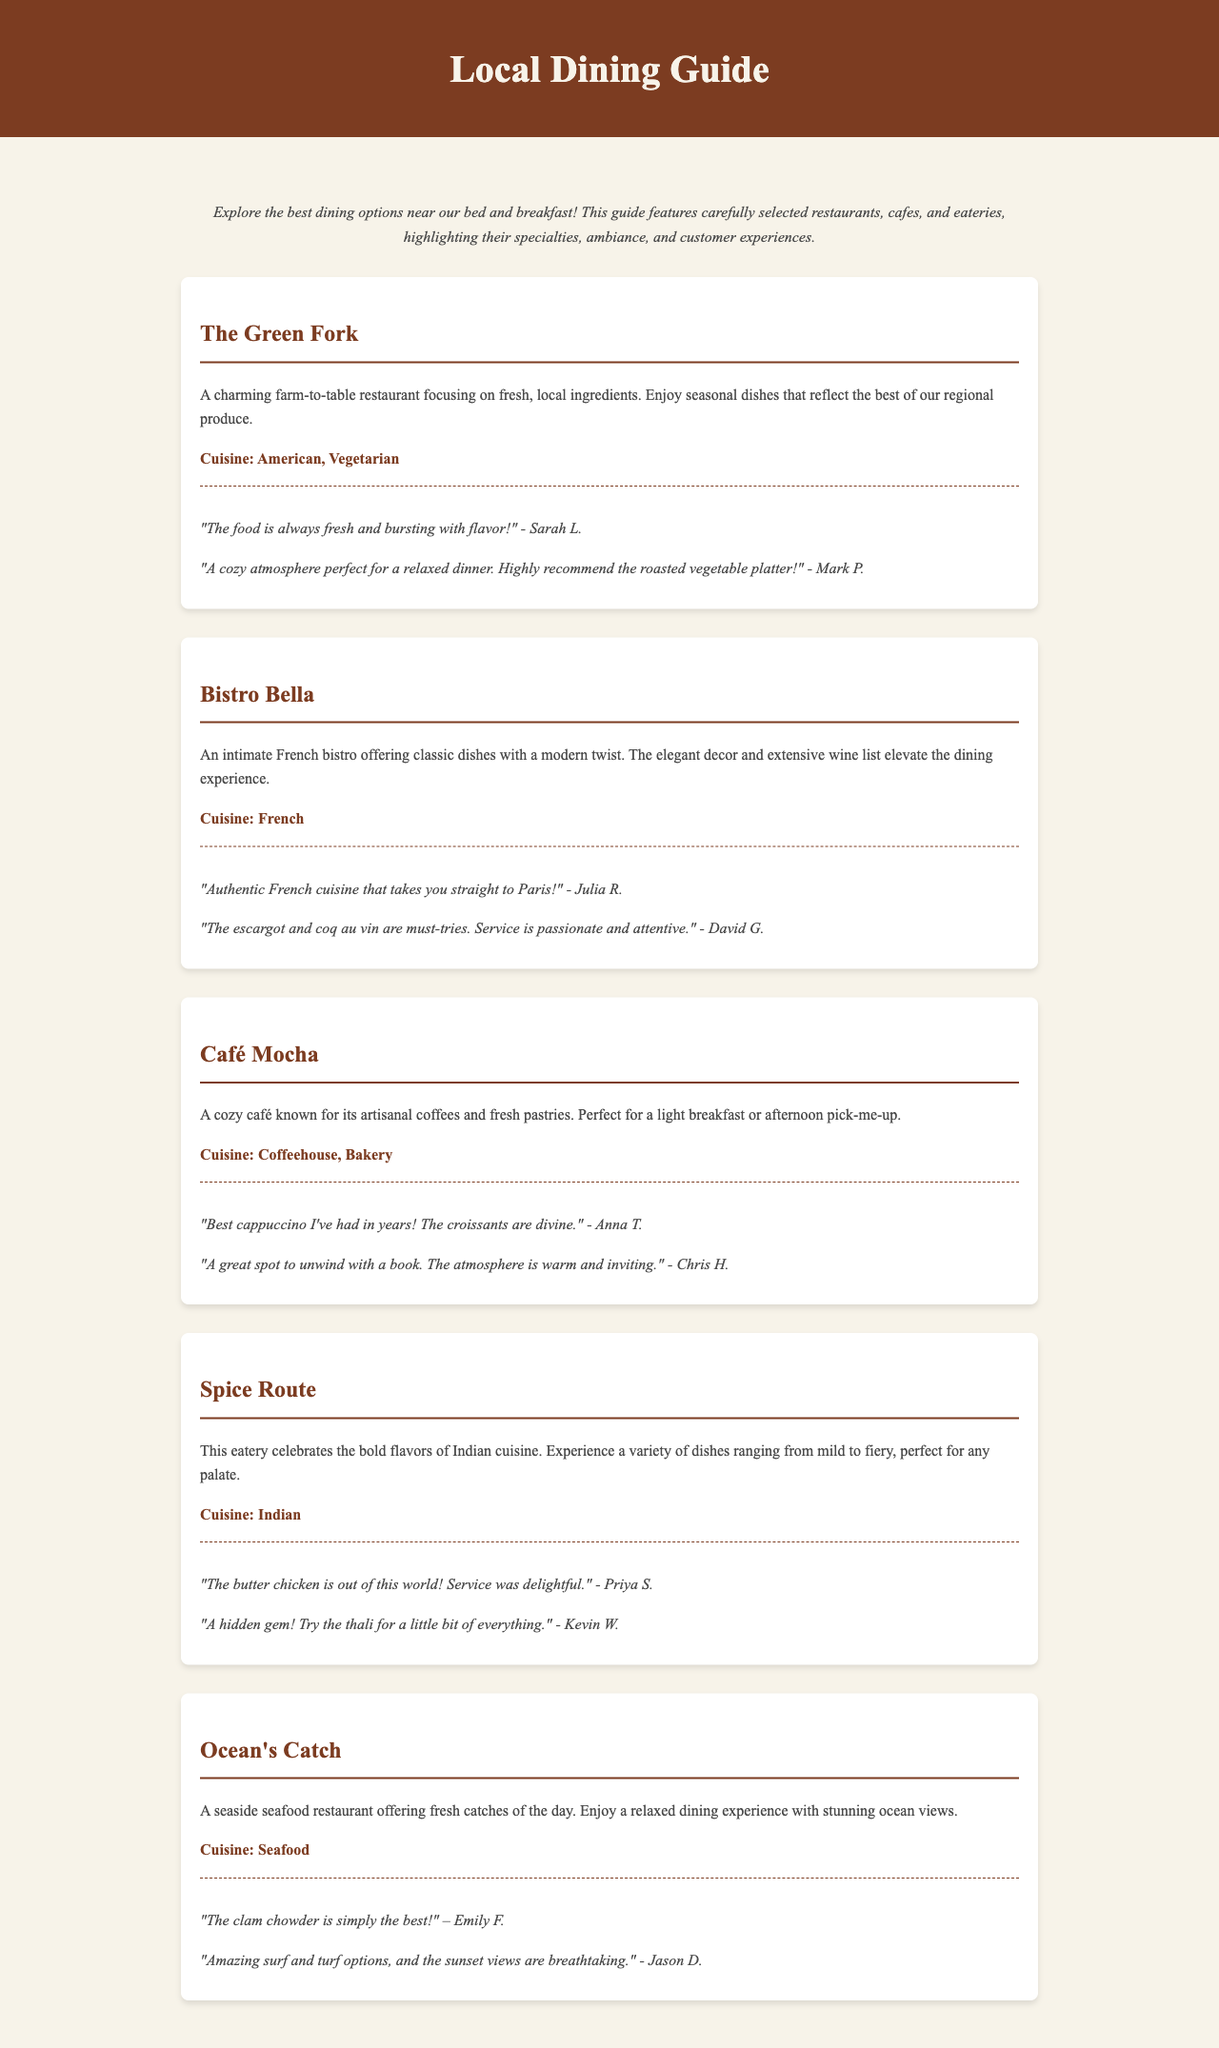What is the name of the farm-to-table restaurant? The document lists several restaurants, including The Green Fork, which is described as a farm-to-table restaurant.
Answer: The Green Fork What type of cuisine is offered at Bistro Bella? The document specifies that Bistro Bella offers French cuisine.
Answer: French Which café is known for its artisanal coffees? Café Mocha is highlighted in the document as a café known for its artisanal coffees and fresh pastries.
Answer: Café Mocha What dish is recommended at Spice Route? The document mentions that the butter chicken is particularly praised at Spice Route.
Answer: Butter chicken How many reviews were featured for Ocean's Catch? The document includes two customer reviews for Ocean's Catch.
Answer: Two Which restaurant focuses on vegetarian dishes? The Green Fork is identified as a farm-to-table restaurant that focuses on fresh, local ingredients and includes vegetarian options.
Answer: The Green Fork What experience does the document state customers can enjoy while dining at Ocean's Catch? The document highlights that customers can enjoy a relaxed dining experience with stunning ocean views at Ocean's Catch.
Answer: Stunning ocean views What is mentioned as a must-try dish at Bistro Bella? The document notes that the escargot and coq au vin are must-tries at Bistro Bella.
Answer: Escargot and coq au vin What atmosphere does Café Mocha offer? Café Mocha is described in the document as having a warm and inviting atmosphere.
Answer: Warm and inviting 